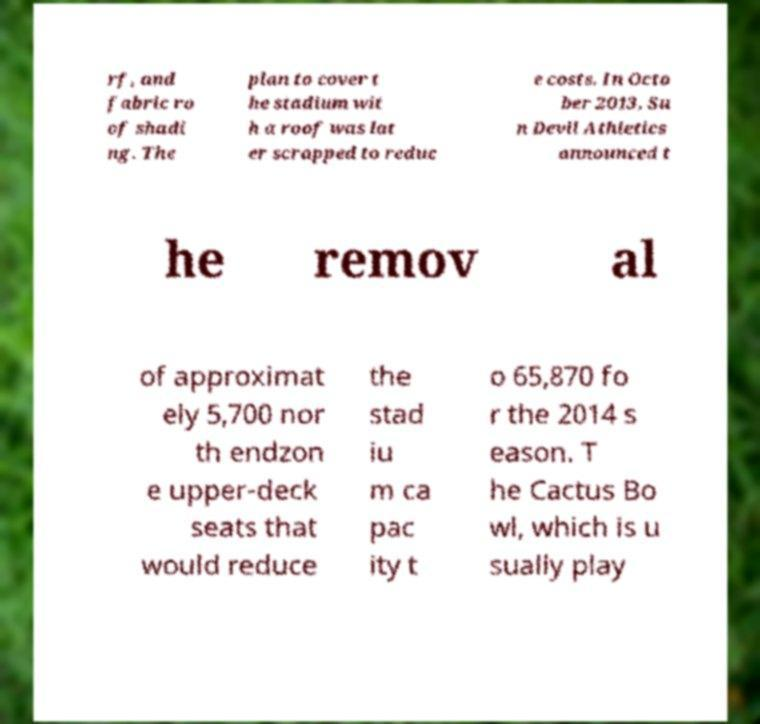I need the written content from this picture converted into text. Can you do that? rf, and fabric ro of shadi ng. The plan to cover t he stadium wit h a roof was lat er scrapped to reduc e costs. In Octo ber 2013, Su n Devil Athletics announced t he remov al of approximat ely 5,700 nor th endzon e upper-deck seats that would reduce the stad iu m ca pac ity t o 65,870 fo r the 2014 s eason. T he Cactus Bo wl, which is u sually play 